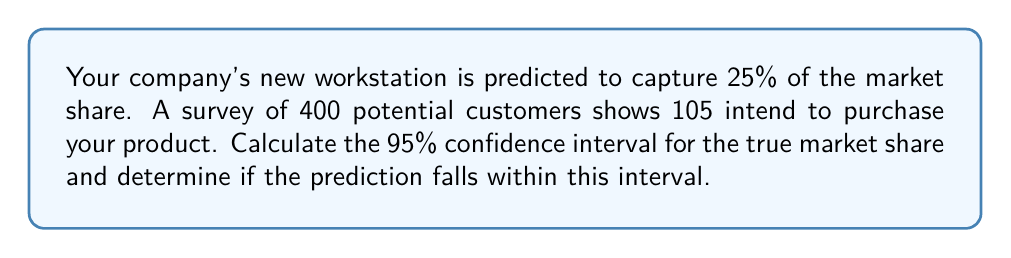Provide a solution to this math problem. Let's approach this step-by-step:

1) First, we need to calculate the sample proportion:
   $\hat{p} = \frac{105}{400} = 0.2625$ or 26.25%

2) For a 95% confidence interval, we use a z-score of 1.96.

3) The formula for the confidence interval is:

   $$\hat{p} \pm z \sqrt{\frac{\hat{p}(1-\hat{p})}{n}}$$

   Where:
   - $\hat{p}$ is the sample proportion
   - $z$ is the z-score (1.96 for 95% confidence)
   - $n$ is the sample size

4) Let's calculate the margin of error:

   $$1.96 \sqrt{\frac{0.2625(1-0.2625)}{400}} = 1.96 \sqrt{\frac{0.19359375}{400}} = 1.96 \times 0.02204 = 0.04320$$

5) Now we can calculate the confidence interval:

   Lower bound: $0.2625 - 0.04320 = 0.21930$ or 21.93%
   Upper bound: $0.2625 + 0.04320 = 0.30570$ or 30.57%

6) The 95% confidence interval is (21.93%, 30.57%).

7) The predicted market share of 25% falls within this interval.
Answer: 95% CI: (21.93%, 30.57%); 25% falls within the interval 